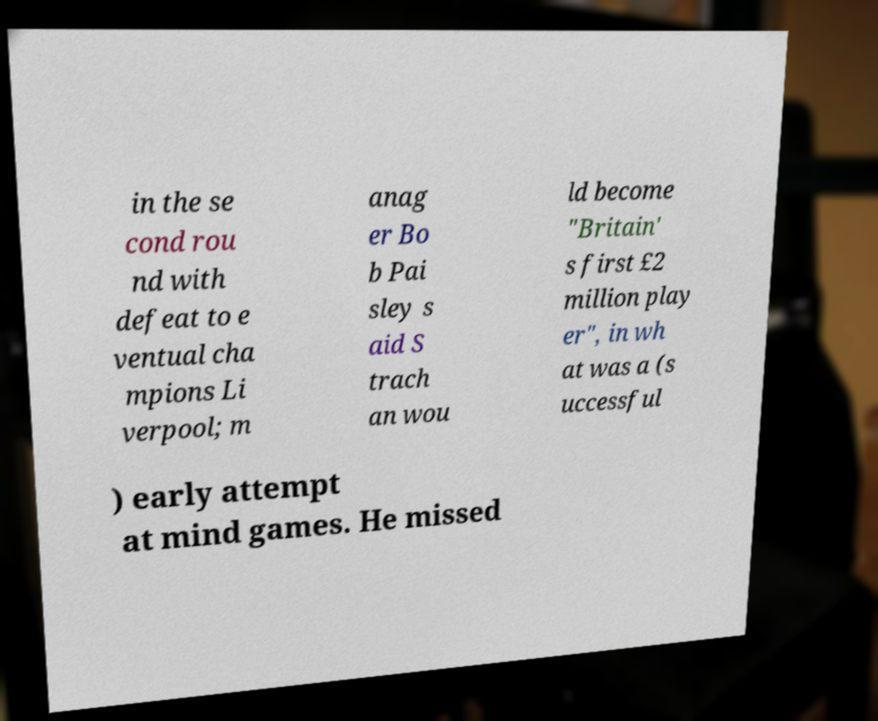Could you extract and type out the text from this image? in the se cond rou nd with defeat to e ventual cha mpions Li verpool; m anag er Bo b Pai sley s aid S trach an wou ld become "Britain' s first £2 million play er", in wh at was a (s uccessful ) early attempt at mind games. He missed 